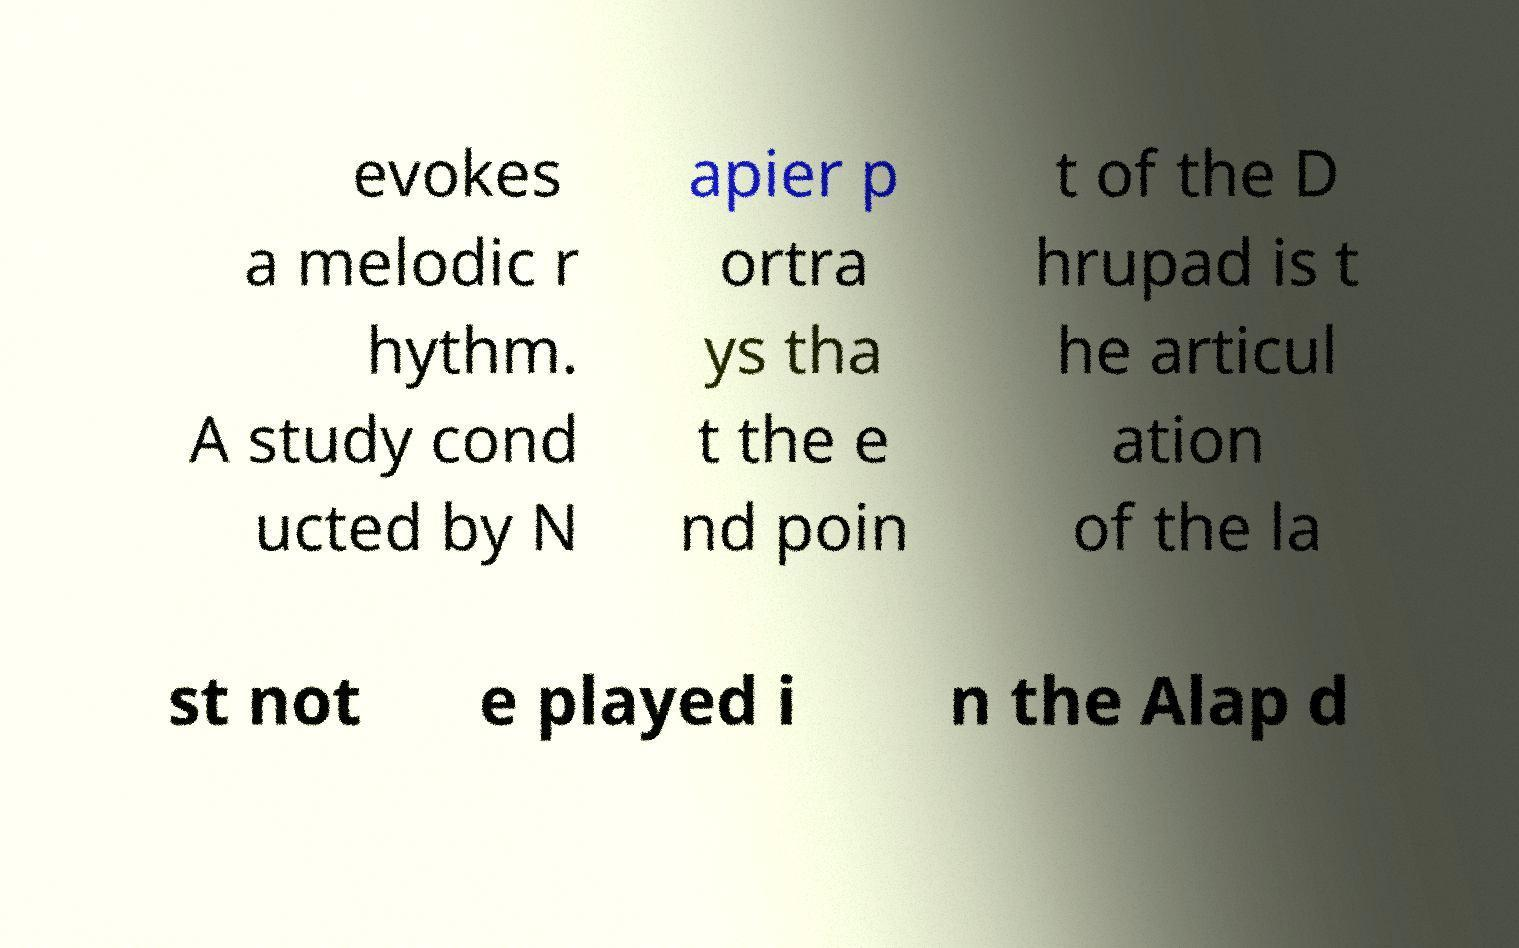For documentation purposes, I need the text within this image transcribed. Could you provide that? evokes a melodic r hythm. A study cond ucted by N apier p ortra ys tha t the e nd poin t of the D hrupad is t he articul ation of the la st not e played i n the Alap d 